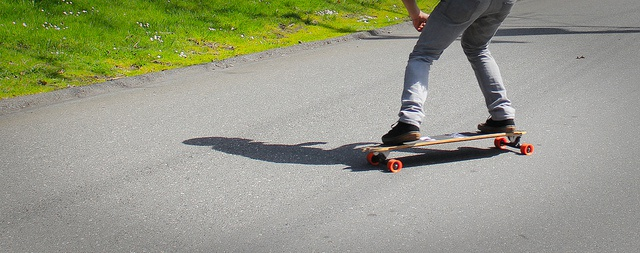Describe the objects in this image and their specific colors. I can see people in green, black, gray, and lightgray tones and skateboard in green, black, darkgray, gray, and maroon tones in this image. 